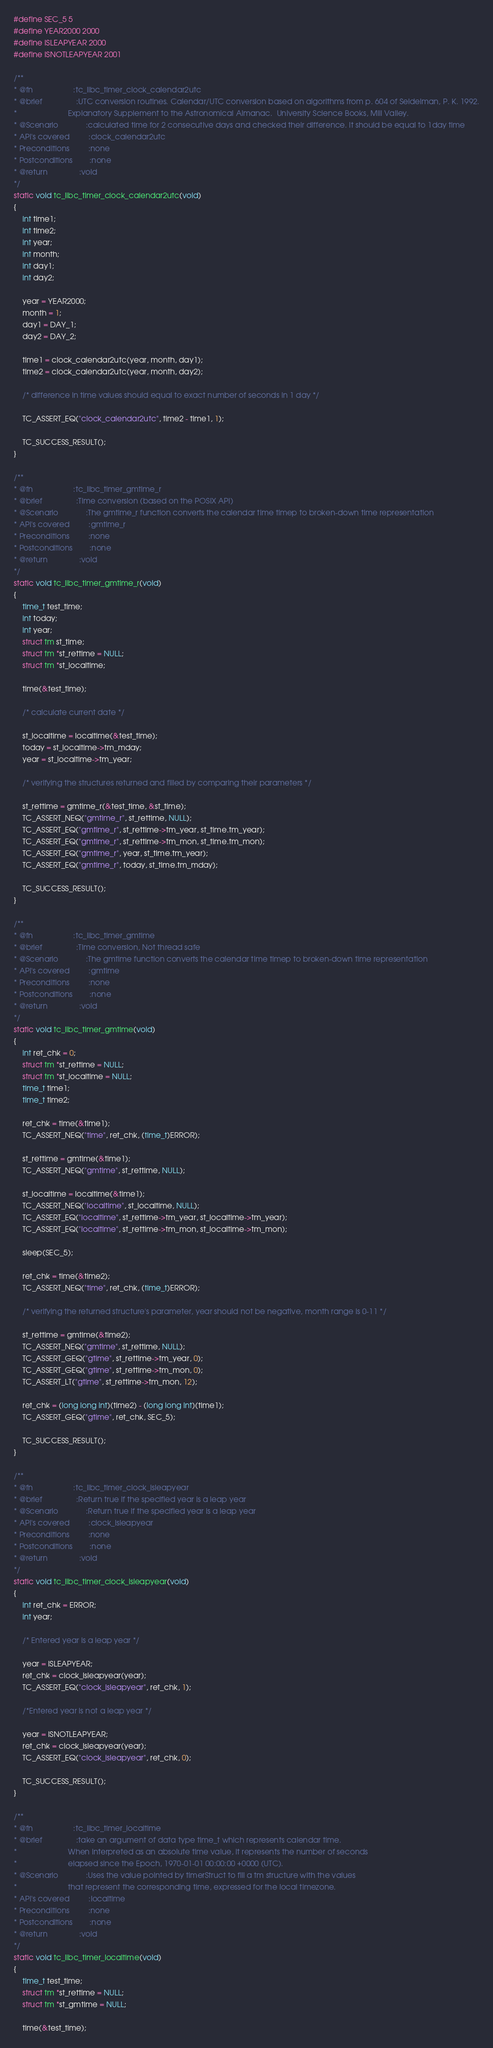Convert code to text. <code><loc_0><loc_0><loc_500><loc_500><_C_>#define SEC_5 5
#define YEAR2000 2000
#define ISLEAPYEAR 2000
#define ISNOTLEAPYEAR 2001

/**
* @fn                   :tc_libc_timer_clock_calendar2utc
* @brief                :UTC conversion routines. Calendar/UTC conversion based on algorithms from p. 604 of Seidelman, P. K. 1992.
*                        Explanatory Supplement to the Astronomical Almanac.  University Science Books, Mill Valley.
* @Scenario             :calculated time for 2 consecutive days and checked their difference. It should be equal to 1day time
* API's covered         :clock_calendar2utc
* Preconditions         :none
* Postconditions        :none
* @return               :void
*/
static void tc_libc_timer_clock_calendar2utc(void)
{
	int time1;
	int time2;
	int year;
	int month;
	int day1;
	int day2;

	year = YEAR2000;
	month = 1;
	day1 = DAY_1;
	day2 = DAY_2;

	time1 = clock_calendar2utc(year, month, day1);
	time2 = clock_calendar2utc(year, month, day2);

	/* difference in time values should equal to exact number of seconds in 1 day */

	TC_ASSERT_EQ("clock_calendar2utc", time2 - time1, 1);

	TC_SUCCESS_RESULT();
}

/**
* @fn                   :tc_libc_timer_gmtime_r
* @brief                :Time conversion (based on the POSIX API)
* @Scenario             :The gmtime_r function converts the calendar time timep to broken-down time representation
* API's covered         :gmtime_r
* Preconditions         :none
* Postconditions        :none
* @return               :void
*/
static void tc_libc_timer_gmtime_r(void)
{
	time_t test_time;
	int today;
	int year;
	struct tm st_time;
	struct tm *st_rettime = NULL;
	struct tm *st_localtime;

	time(&test_time);

	/* calculate current date */

	st_localtime = localtime(&test_time);
	today = st_localtime->tm_mday;
	year = st_localtime->tm_year;

	/* verifying the structures returned and filled by comparing their parameters */

	st_rettime = gmtime_r(&test_time, &st_time);
	TC_ASSERT_NEQ("gmtime_r", st_rettime, NULL);
	TC_ASSERT_EQ("gmtime_r", st_rettime->tm_year, st_time.tm_year);
	TC_ASSERT_EQ("gmtime_r", st_rettime->tm_mon, st_time.tm_mon);
	TC_ASSERT_EQ("gmtime_r", year, st_time.tm_year);
	TC_ASSERT_EQ("gmtime_r", today, st_time.tm_mday);

	TC_SUCCESS_RESULT();
}

/**
* @fn                   :tc_libc_timer_gmtime
* @brief                :Time conversion, Not thread safe
* @Scenario             :The gmtime function converts the calendar time timep to broken-down time representation
* API's covered         :gmtime
* Preconditions         :none
* Postconditions        :none
* @return               :void
*/
static void tc_libc_timer_gmtime(void)
{
	int ret_chk = 0;
	struct tm *st_rettime = NULL;
	struct tm *st_localtime = NULL;
	time_t time1;
	time_t time2;

	ret_chk = time(&time1);
	TC_ASSERT_NEQ("time", ret_chk, (time_t)ERROR);

	st_rettime = gmtime(&time1);
	TC_ASSERT_NEQ("gmtime", st_rettime, NULL);

	st_localtime = localtime(&time1);
	TC_ASSERT_NEQ("localtime", st_localtime, NULL);
	TC_ASSERT_EQ("localtime", st_rettime->tm_year, st_localtime->tm_year);
	TC_ASSERT_EQ("localtime", st_rettime->tm_mon, st_localtime->tm_mon);

	sleep(SEC_5);

	ret_chk = time(&time2);
	TC_ASSERT_NEQ("time", ret_chk, (time_t)ERROR);

	/* verifying the returned structure's parameter, year should not be negative, month range is 0-11 */

	st_rettime = gmtime(&time2);
	TC_ASSERT_NEQ("gmtime", st_rettime, NULL);
	TC_ASSERT_GEQ("gtime", st_rettime->tm_year, 0);
	TC_ASSERT_GEQ("gtime", st_rettime->tm_mon, 0);
	TC_ASSERT_LT("gtime", st_rettime->tm_mon, 12);

	ret_chk = (long long int)(time2) - (long long int)(time1);
	TC_ASSERT_GEQ("gtime", ret_chk, SEC_5);

	TC_SUCCESS_RESULT();
}

/**
* @fn                   :tc_libc_timer_clock_isleapyear
* @brief                :Return true if the specified year is a leap year
* @Scenario             :Return true if the specified year is a leap year
* API's covered         :clock_isleapyear
* Preconditions         :none
* Postconditions        :none
* @return               :void
*/
static void tc_libc_timer_clock_isleapyear(void)
{
	int ret_chk = ERROR;
	int year;

	/* Entered year is a leap year */

	year = ISLEAPYEAR;
	ret_chk = clock_isleapyear(year);
	TC_ASSERT_EQ("clock_isleapyear", ret_chk, 1);

	/*Entered year is not a leap year */

	year = ISNOTLEAPYEAR;
	ret_chk = clock_isleapyear(year);
	TC_ASSERT_EQ("clock_isleapyear", ret_chk, 0);

	TC_SUCCESS_RESULT();
}

/**
* @fn                   :tc_libc_timer_localtime
* @brief                :take an argument of data type time_t which represents calendar time.
*                        When interpreted as an absolute time value, it represents the number of seconds
*                        elapsed since the Epoch, 1970-01-01 00:00:00 +0000 (UTC).
* @Scenario             :Uses the value pointed by timerStruct to fill a tm structure with the values
*                        that represent the corresponding time, expressed for the local timezone.
* API's covered         :localtime
* Preconditions         :none
* Postconditions        :none
* @return               :void
*/
static void tc_libc_timer_localtime(void)
{
	time_t test_time;
	struct tm *st_rettime = NULL;
	struct tm *st_gmtime = NULL;

	time(&test_time);</code> 